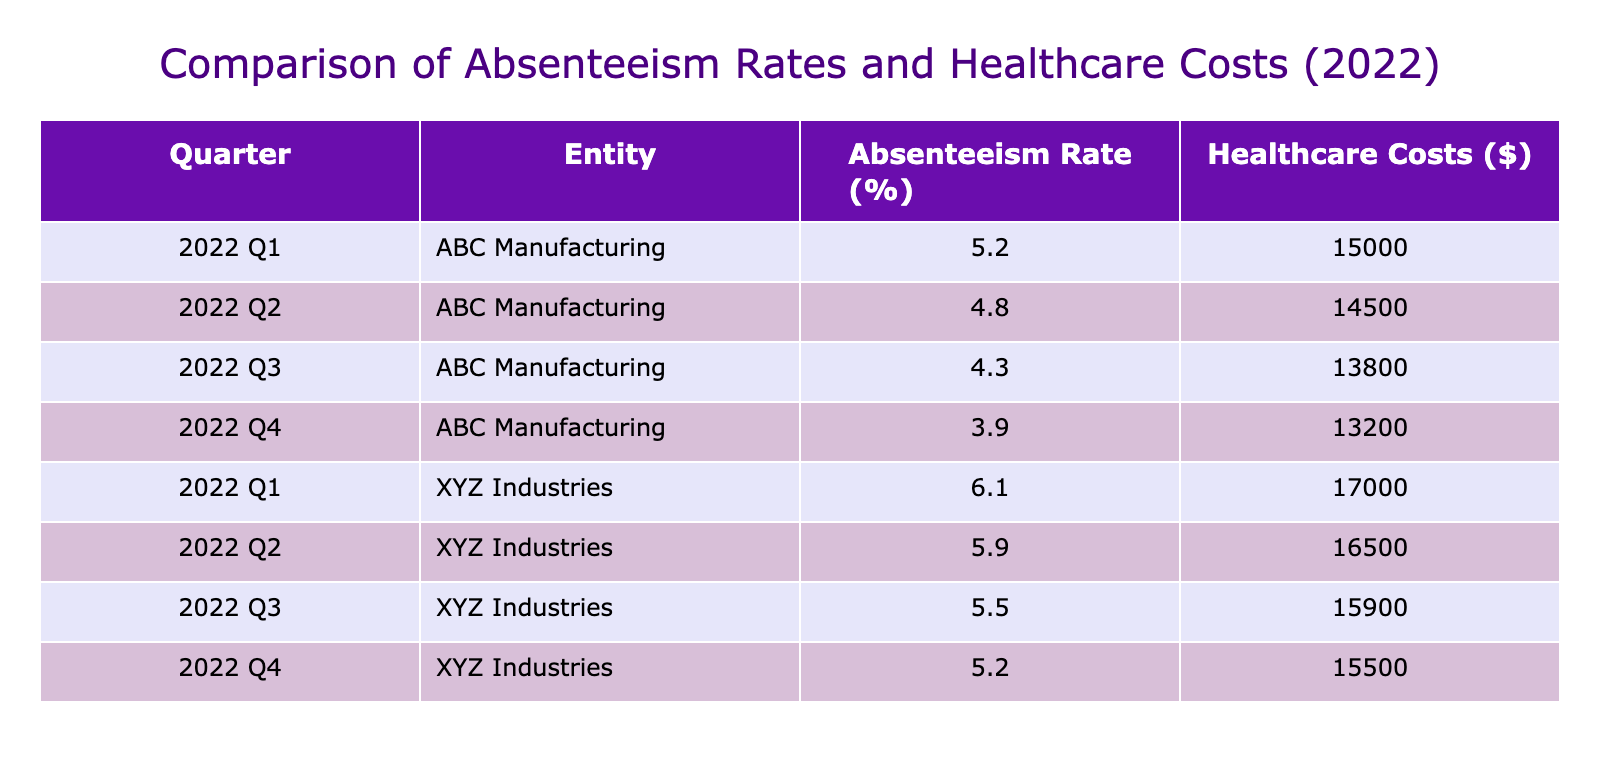What was the absenteeism rate for ABC Manufacturing in Q1 2022? The table indicates that for ABC Manufacturing in the first quarter of 2022, the absenteeism rate is listed as 5.2%.
Answer: 5.2% What were the healthcare costs for XYZ Industries in Q3 2022? Referring to the table, XYZ Industries had healthcare costs of 15,900 dollars in the third quarter of 2022.
Answer: 15,900 Which company had the lowest absenteeism rate in Q4 2022? In the fourth quarter of 2022, ABC Manufacturing had an absenteeism rate of 3.9%, while XYZ Industries had 5.2%. Thus, ABC Manufacturing had the lowest rate.
Answer: ABC Manufacturing What was the total absenteeism rate for ABC Manufacturing across all four quarters of 2022? Adding the absenteeism rates for ABC Manufacturing: 5.2 + 4.8 + 4.3 + 3.9 = 18.2. This is the total absenteeism rate for the year.
Answer: 18.2 Did healthcare costs for ABC Manufacturing decrease from Q1 to Q4 in 2022? By comparing Q1's healthcare costs of 15,000 dollars to Q4's costs of 13,200 dollars, we see a decrease of 1,800 dollars over the year. Therefore, it is true that costs decreased.
Answer: Yes What is the average absenteeism rate for XYZ Industries over all four quarters? Calculating the average involves summing the absenteeism rates: 6.1 + 5.9 + 5.5 + 5.2 = 22.7, and then dividing by the number of quarters (4), gives an average of 5.675.
Answer: 5.675 Did both companies see a decrease in healthcare costs from Q1 to Q4 in 2022? For ABC Manufacturing, healthcare costs decreased from 15,000 dollars to 13,200 dollars. For XYZ Industries, costs decreased from 17,000 dollars to 15,500 dollars as well. Both companies saw decreases.
Answer: Yes What was the difference in total healthcare costs between the two companies in Q2 2022? In Q2 2022, ABC Manufacturing had healthcare costs of 14,500 dollars, and XYZ Industries had 16,500 dollars. The difference is 16,500 - 14,500 = 2,000 dollars.
Answer: 2,000 What is the trend in absenteeism rates for ABC Manufacturing across the year? By examining the absenteeism rates provided in the table (5.2, 4.8, 4.3, 3.9), it can be observed that the rates consistently decreased each quarter, indicating a downward trend.
Answer: Downward trend 